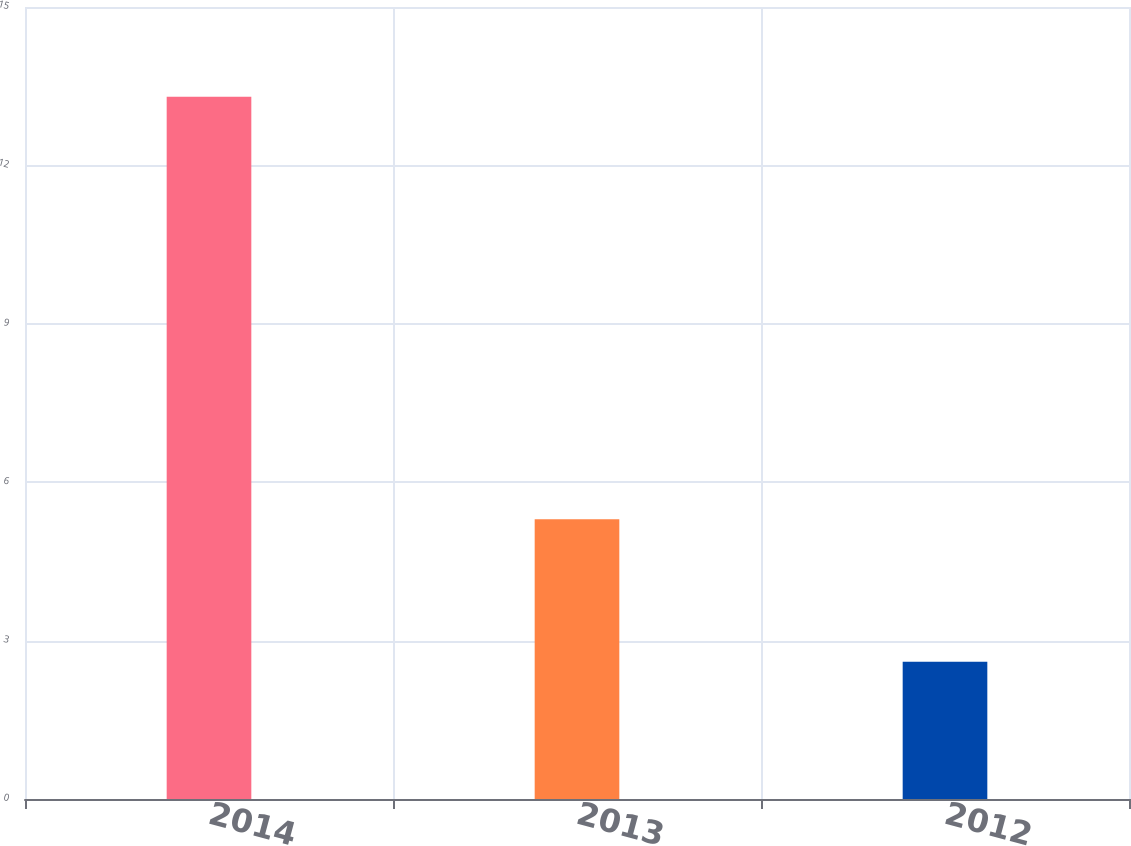Convert chart to OTSL. <chart><loc_0><loc_0><loc_500><loc_500><bar_chart><fcel>2014<fcel>2013<fcel>2012<nl><fcel>13.3<fcel>5.3<fcel>2.6<nl></chart> 